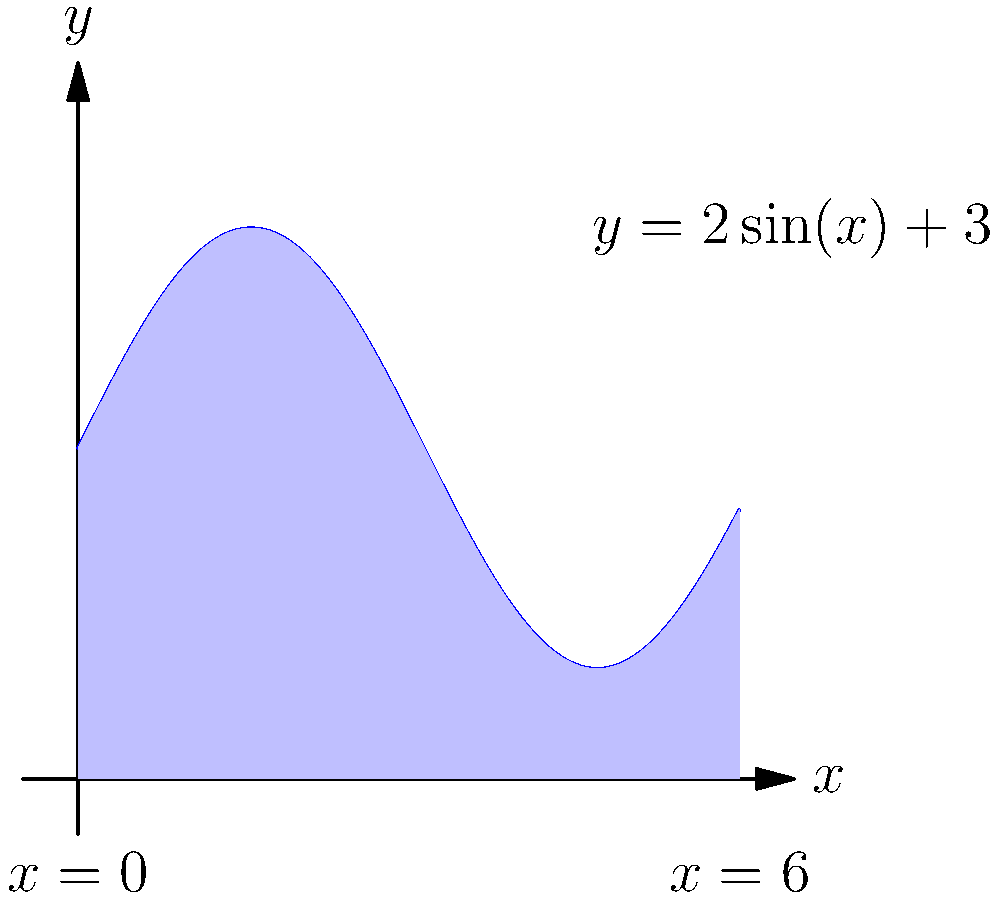As a property agent, you're tasked with determining the area of an irregularly shaped lot. The lot's boundary can be modeled by the function $y = 2\sin(x) + 3$ from $x=0$ to $x=6$ (in meters). Calculate the total area of the lot using integration. To find the area of the irregularly shaped lot, we need to integrate the given function over the specified interval. Here's how we can approach this:

1) The function describing the lot's boundary is $y = 2\sin(x) + 3$.

2) We need to integrate this function from $x=0$ to $x=6$.

3) The formula for the area under a curve is:

   $$A = \int_{a}^{b} f(x) dx$$

4) Substituting our function and limits:

   $$A = \int_{0}^{6} (2\sin(x) + 3) dx$$

5) We can split this into two integrals:

   $$A = \int_{0}^{6} 2\sin(x) dx + \int_{0}^{6} 3 dx$$

6) For the first integral, we know that $\int \sin(x) dx = -\cos(x) + C$:

   $$\int_{0}^{6} 2\sin(x) dx = [-2\cos(x)]_{0}^{6} = -2\cos(6) - (-2\cos(0)) = -2\cos(6) + 2$$

7) For the second integral:

   $$\int_{0}^{6} 3 dx = [3x]_{0}^{6} = 18 - 0 = 18$$

8) Adding these results:

   $$A = (-2\cos(6) + 2) + 18 = -2\cos(6) + 20$$

9) Using a calculator or knowing that $\cos(6) \approx 0.96$:

   $$A \approx -2(0.96) + 20 \approx 18.08$$

Therefore, the area of the lot is approximately 18.08 square meters.
Answer: 18.08 m² 